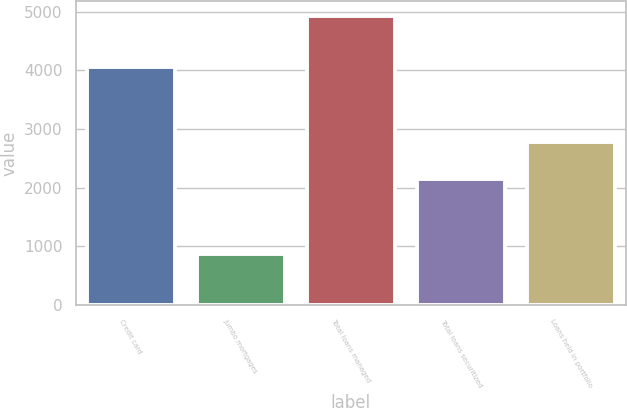Convert chart to OTSL. <chart><loc_0><loc_0><loc_500><loc_500><bar_chart><fcel>Credit card<fcel>Jumbo mortgages<fcel>Total loans managed<fcel>Total loans securitized<fcel>Loans held in portfolio<nl><fcel>4061<fcel>866<fcel>4927<fcel>2143<fcel>2775<nl></chart> 